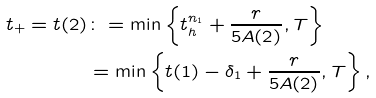<formula> <loc_0><loc_0><loc_500><loc_500>t _ { + } = t ( 2 ) & \colon = \min \left \{ t _ { h } ^ { n _ { 1 } } + \frac { r } { 5 A ( 2 ) } , T \right \} \\ & = \min \left \{ t ( 1 ) - \delta _ { 1 } + \frac { r } { 5 A ( 2 ) } , T \right \} ,</formula> 